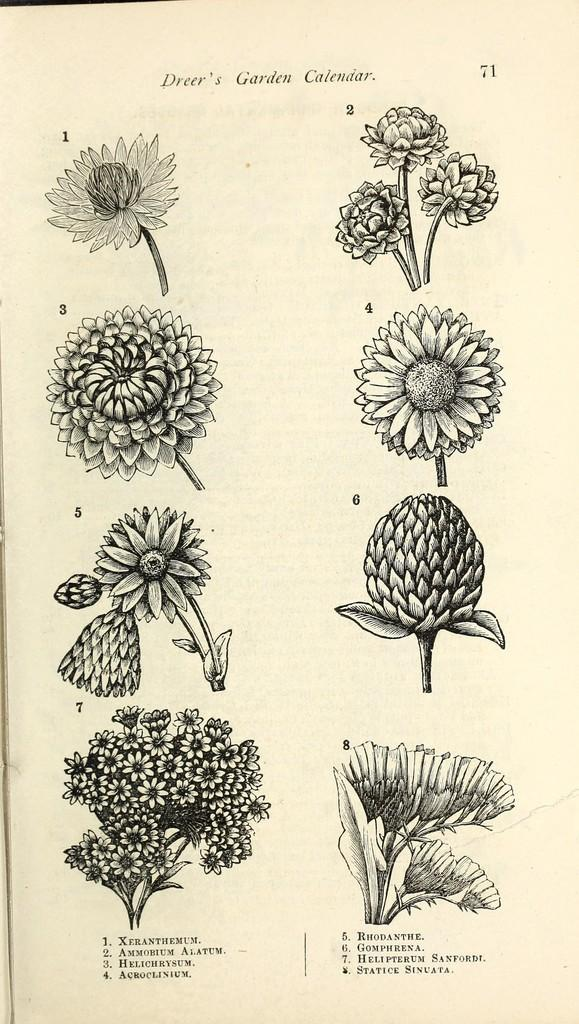What is the main subject of the image? There is a photo in the image. What can be seen in the photo? The photo contains flowers. What type of cake is being served in the image? There is no cake present in the image; it only contains a photo with flowers. What month is it in the image? The image does not provide any information about the month or time of year. 